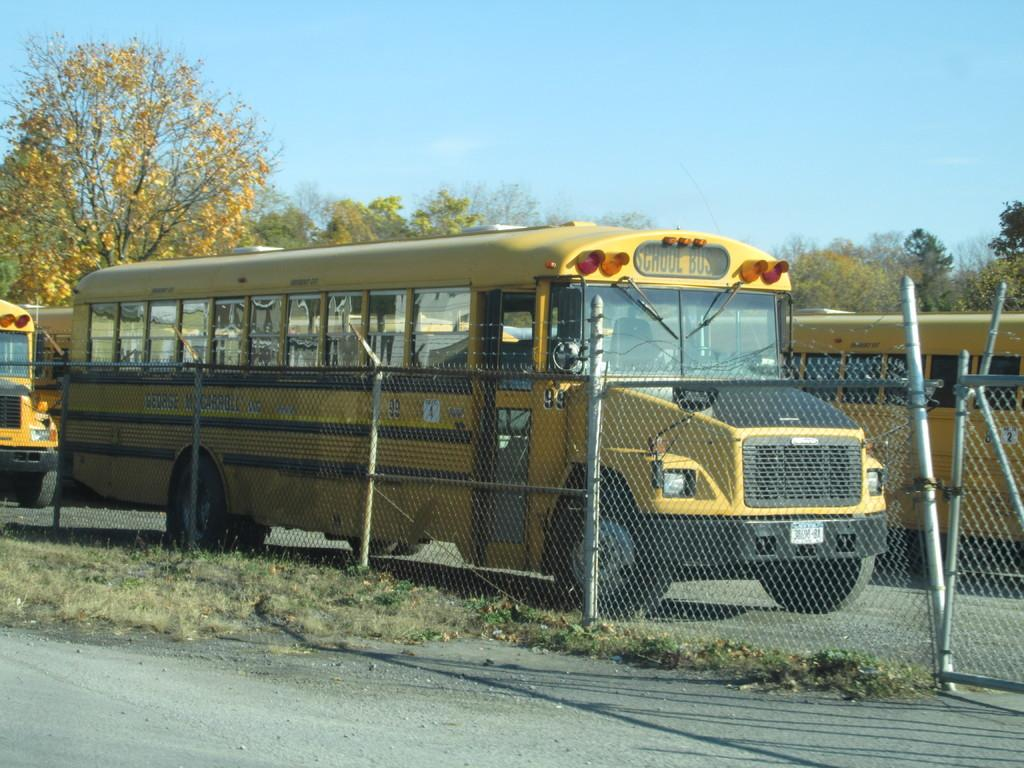<image>
Share a concise interpretation of the image provided. A yellow bus parked behind a fence with school bus on the top. 